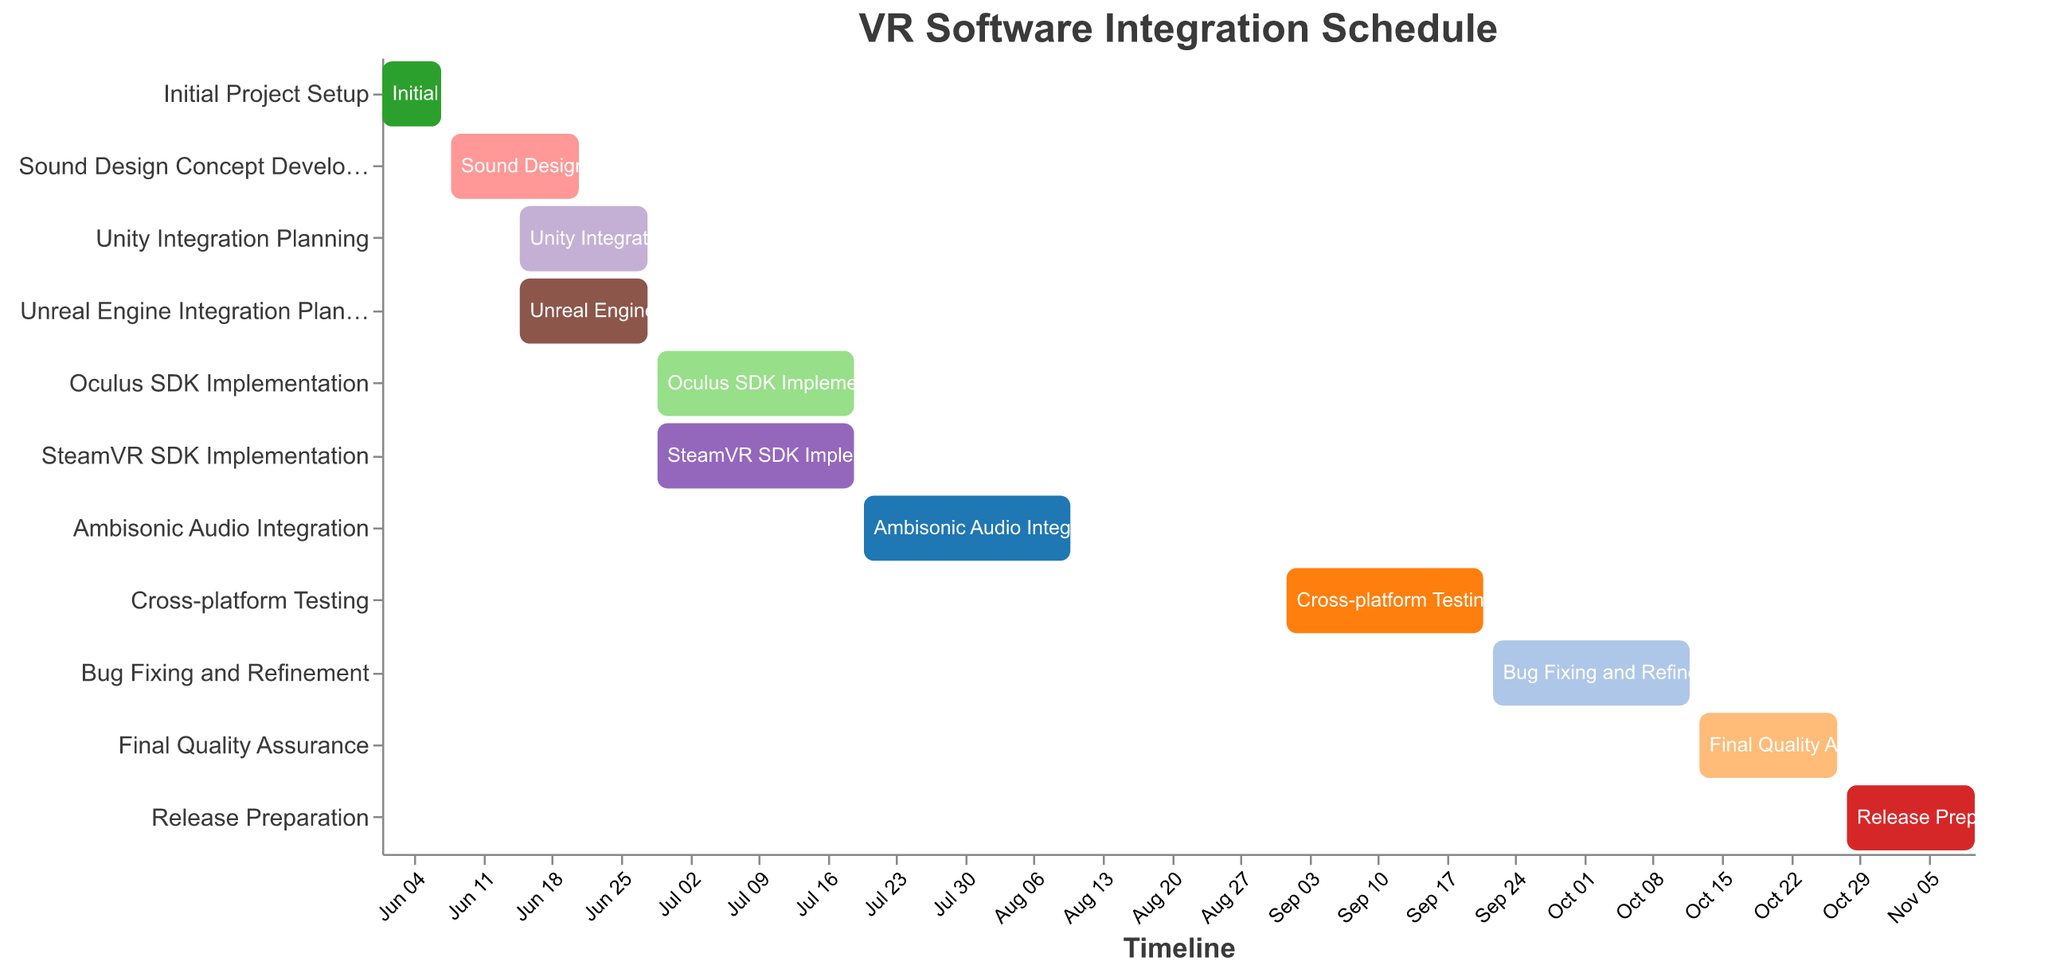What is the title of the Gantt Chart? The title of the Gantt Chart is displayed prominently at the top of the figure.
Answer: VR Software Integration Schedule Which task starts immediately after "Sound Design Concept Development"? The Gantt Chart shows task dependencies and timelines. "Ambisonic Audio Integration" starts after "Sound Design Concept Development".
Answer: Ambisonic Audio Integration How long does the "Oculus SDK Implementation" task take? The Gantt Chart shows the start and end dates for each task. "Oculus SDK Implementation" runs from June 29 to July 19, which is 21 days in total.
Answer: 21 days What is the duration of "Cross-platform Testing"? According to the figure, the "Cross-platform Testing" runs from September 1 to September 21. The difference between these dates is 21 days.
Answer: 21 days What are the dependencies for "Release Preparation"? The Gantt Chart lists dependencies for each task in a specific column. "Release Preparation" depends on "Final Quality Assurance".
Answer: Final Quality Assurance Which task has the latest end date in the Gantt Chart? By examining the timeline axis and the end dates of all tasks, "Release Preparation" ends last on November 10.
Answer: Release Preparation Are there overlapping tasks in July 2023? Looking at the Gantt Chart, "Oculus SDK Implementation" and "SteamVR SDK Implementation" overlap with "Ambisonic Audio Integration" in July 2023.
Answer: Yes What tasks are dependent on "Initial Project Setup"? Refer to the "Dependencies" listed in the Gantt Chart. "Sound Design Concept Development," "Unity Integration Planning," and "Unreal Engine Integration Planning" depend on "Initial Project Setup".
Answer: Sound Design Concept Development, Unity Integration Planning, Unreal Engine Integration Planning Which task lasts the shortest duration? The Gantt Chart shows timelines for each task. "Initial Project Setup" from June 1 to June 7 is the shortest, taking 7 days.
Answer: Initial Project Setup Which tasks require the completion of "Unreal Engine Integration Planning" before they can start? The figure shows task dependencies. "SteamVR SDK Implementation" requires the completion of "Unreal Engine Integration Planning".
Answer: SteamVR SDK Implementation 